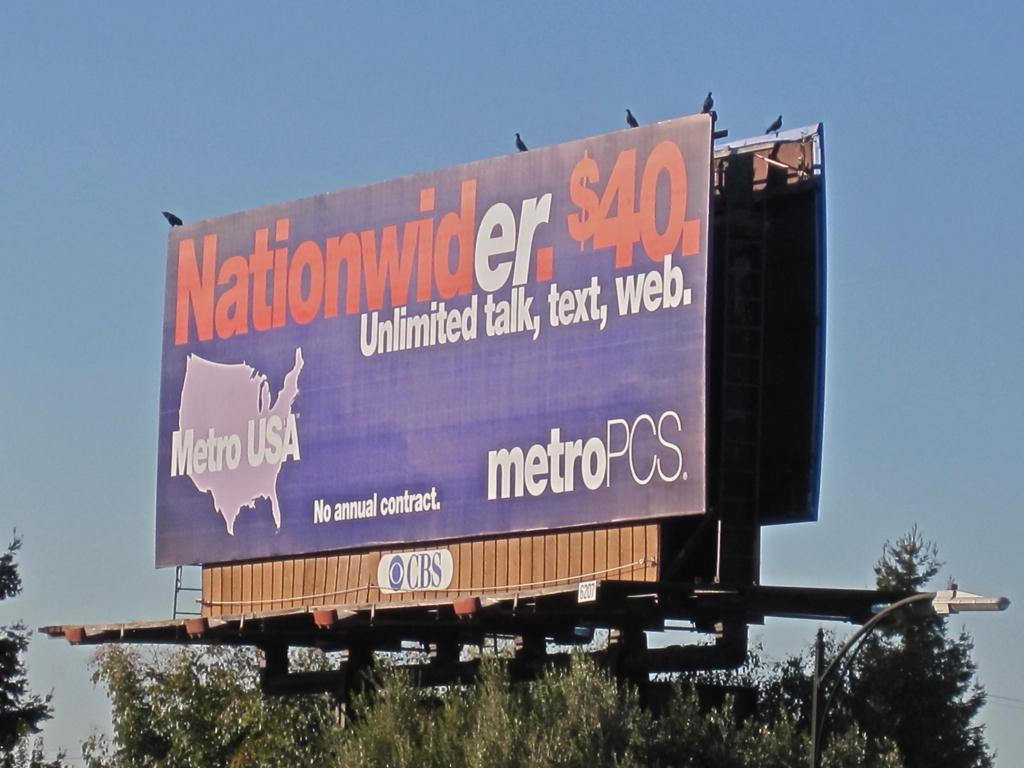<image>
Describe the image concisely. The cell phone carrier on the sign is Metro USA. 